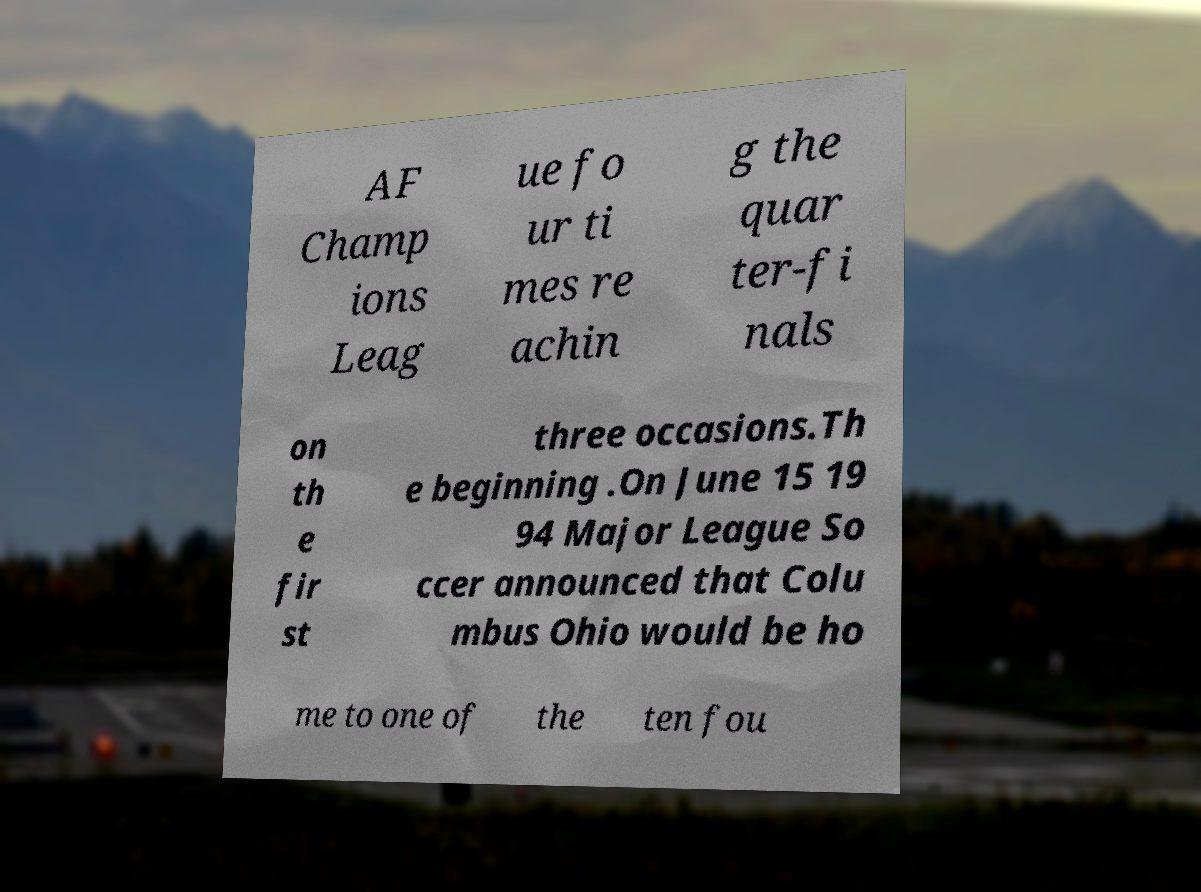For documentation purposes, I need the text within this image transcribed. Could you provide that? AF Champ ions Leag ue fo ur ti mes re achin g the quar ter-fi nals on th e fir st three occasions.Th e beginning .On June 15 19 94 Major League So ccer announced that Colu mbus Ohio would be ho me to one of the ten fou 